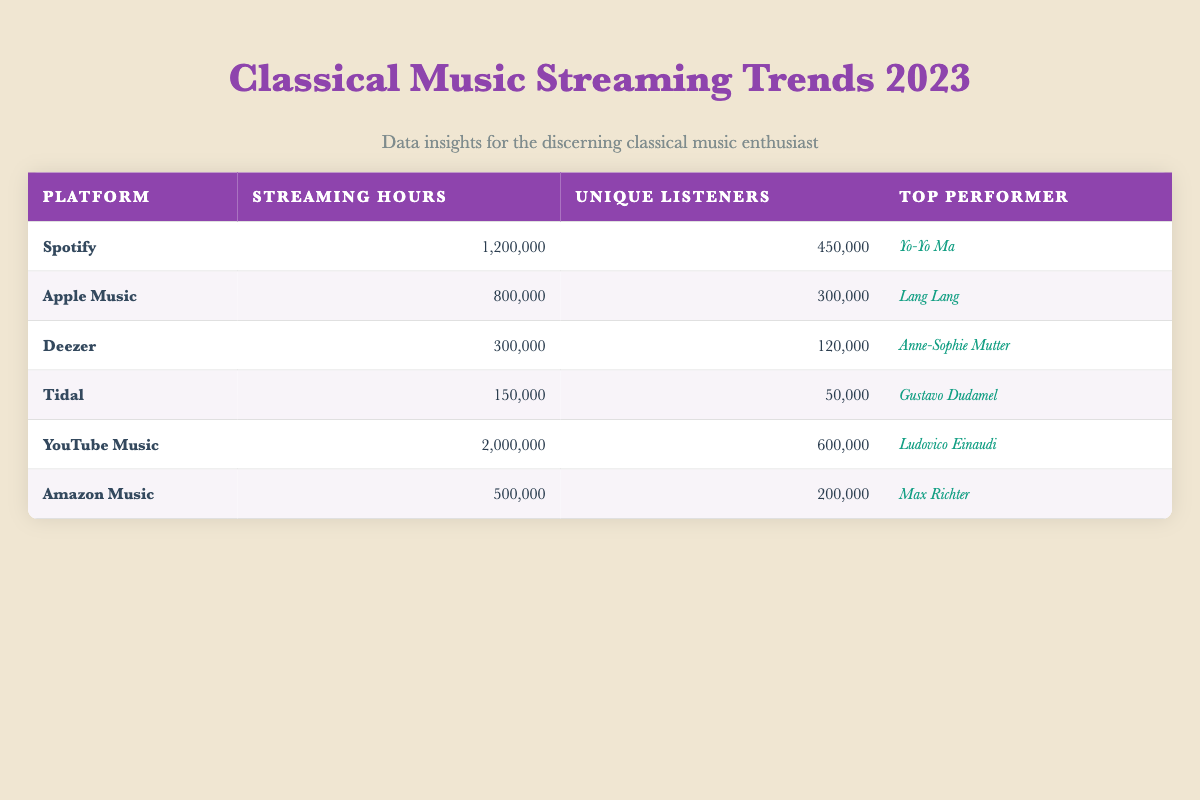What is the total streaming hours across all platforms for classical music in 2023? To calculate the total streaming hours, add the streaming hours for each platform: 1200000 (Spotify) + 800000 (Apple Music) + 300000 (Deezer) + 150000 (Tidal) + 2000000 (YouTube Music) + 500000 (Amazon Music) = 4460000
Answer: 4460000 Which platform has the highest number of unique listeners? By comparing the unique listeners for each platform, YouTube Music has the highest with 600000, while the next highest is Spotify with 450000.
Answer: YouTube Music Is Yo-Yo Ma the top performer on any other platform besides Spotify? According to the table, Yo-Yo Ma is only listed as the top performer on Spotify, with Lang Lang on Apple Music, Anne-Sophie Mutter on Deezer, and others on their respective platforms.
Answer: No What is the difference in streaming hours between YouTube Music and Tidal? YouTube Music has 2000000 streaming hours, while Tidal has 150000. The difference is 2000000 - 150000 = 1850000.
Answer: 1850000 On which platform is Anne-Sophie Mutter the top performer? The table indicates that Anne-Sophie Mutter is the top performer on Deezer.
Answer: Deezer What is the average number of unique listeners across all platforms? To find the average, sum the unique listeners: 450000 (Spotify) + 300000 (Apple Music) + 120000 (Deezer) + 50000 (Tidal) + 600000 (YouTube Music) + 200000 (Amazon Music) = 1725000. Since there are 6 platforms, divide by 6: 1725000 / 6 = 287500.
Answer: 287500 Did Tidal have more streaming hours than Deezer? Tidal has 150000 streaming hours, while Deezer has 300000. Since 150000 is less than 300000, Tidal did not have more streaming hours.
Answer: No Which classical music performer has the least unique listeners? Tidal's top performer, Gustavo Dudamel, is associated with the least number of unique listeners at 50000, compared to others.
Answer: Gustavo Dudamel 